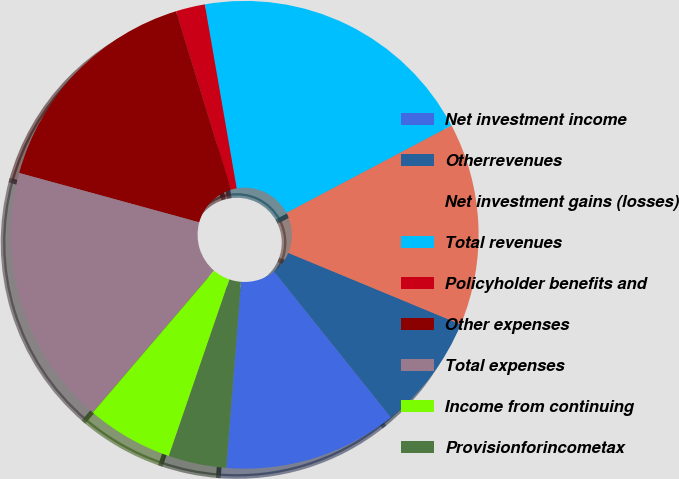<chart> <loc_0><loc_0><loc_500><loc_500><pie_chart><fcel>Net investment income<fcel>Otherrevenues<fcel>Net investment gains (losses)<fcel>Total revenues<fcel>Policyholder benefits and<fcel>Other expenses<fcel>Total expenses<fcel>Income from continuing<fcel>Provisionforincometax<nl><fcel>12.0%<fcel>8.0%<fcel>14.0%<fcel>19.99%<fcel>2.01%<fcel>16.0%<fcel>18.0%<fcel>6.0%<fcel>4.0%<nl></chart> 